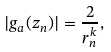<formula> <loc_0><loc_0><loc_500><loc_500>| g _ { a } ( z _ { n } ) | = \frac { 2 } { r _ { n } ^ { k } } ,</formula> 